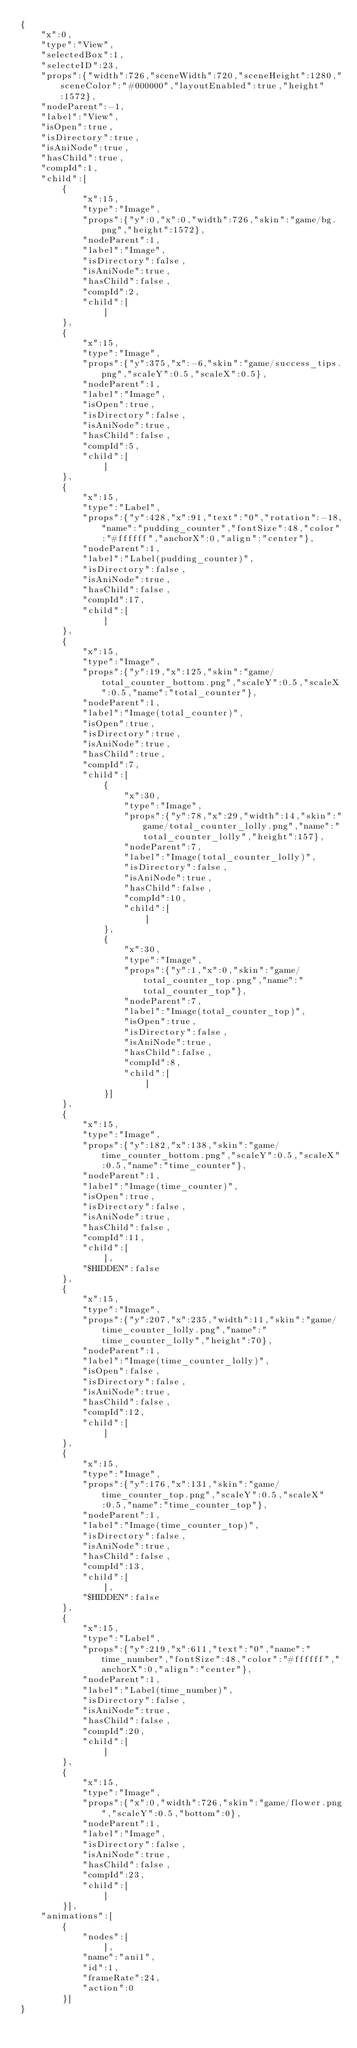<code> <loc_0><loc_0><loc_500><loc_500><_XML_>{
    "x":0,
    "type":"View",
    "selectedBox":1,
    "selecteID":23,
    "props":{"width":726,"sceneWidth":720,"sceneHeight":1280,"sceneColor":"#000000","layoutEnabled":true,"height":1572},
    "nodeParent":-1,
    "label":"View",
    "isOpen":true,
    "isDirectory":true,
    "isAniNode":true,
    "hasChild":true,
    "compId":1,
    "child":[
        {
            "x":15,
            "type":"Image",
            "props":{"y":0,"x":0,"width":726,"skin":"game/bg.png","height":1572},
            "nodeParent":1,
            "label":"Image",
            "isDirectory":false,
            "isAniNode":true,
            "hasChild":false,
            "compId":2,
            "child":[
                ]
        },
        {
            "x":15,
            "type":"Image",
            "props":{"y":375,"x":-6,"skin":"game/success_tips.png","scaleY":0.5,"scaleX":0.5},
            "nodeParent":1,
            "label":"Image",
            "isOpen":true,
            "isDirectory":false,
            "isAniNode":true,
            "hasChild":false,
            "compId":5,
            "child":[
                ]
        },
        {
            "x":15,
            "type":"Label",
            "props":{"y":428,"x":91,"text":"0","rotation":-18,"name":"pudding_counter","fontSize":48,"color":"#ffffff","anchorX":0,"align":"center"},
            "nodeParent":1,
            "label":"Label(pudding_counter)",
            "isDirectory":false,
            "isAniNode":true,
            "hasChild":false,
            "compId":17,
            "child":[
                ]
        },
        {
            "x":15,
            "type":"Image",
            "props":{"y":19,"x":125,"skin":"game/total_counter_bottom.png","scaleY":0.5,"scaleX":0.5,"name":"total_counter"},
            "nodeParent":1,
            "label":"Image(total_counter)",
            "isOpen":true,
            "isDirectory":true,
            "isAniNode":true,
            "hasChild":true,
            "compId":7,
            "child":[
                {
                    "x":30,
                    "type":"Image",
                    "props":{"y":78,"x":29,"width":14,"skin":"game/total_counter_lolly.png","name":"total_counter_lolly","height":157},
                    "nodeParent":7,
                    "label":"Image(total_counter_lolly)",
                    "isDirectory":false,
                    "isAniNode":true,
                    "hasChild":false,
                    "compId":10,
                    "child":[
                        ]
                },
                {
                    "x":30,
                    "type":"Image",
                    "props":{"y":1,"x":0,"skin":"game/total_counter_top.png","name":"total_counter_top"},
                    "nodeParent":7,
                    "label":"Image(total_counter_top)",
                    "isOpen":true,
                    "isDirectory":false,
                    "isAniNode":true,
                    "hasChild":false,
                    "compId":8,
                    "child":[
                        ]
                }]
        },
        {
            "x":15,
            "type":"Image",
            "props":{"y":182,"x":138,"skin":"game/time_counter_bottom.png","scaleY":0.5,"scaleX":0.5,"name":"time_counter"},
            "nodeParent":1,
            "label":"Image(time_counter)",
            "isOpen":true,
            "isDirectory":false,
            "isAniNode":true,
            "hasChild":false,
            "compId":11,
            "child":[
                ],
            "$HIDDEN":false
        },
        {
            "x":15,
            "type":"Image",
            "props":{"y":207,"x":235,"width":11,"skin":"game/time_counter_lolly.png","name":"time_counter_lolly","height":70},
            "nodeParent":1,
            "label":"Image(time_counter_lolly)",
            "isOpen":false,
            "isDirectory":false,
            "isAniNode":true,
            "hasChild":false,
            "compId":12,
            "child":[
                ]
        },
        {
            "x":15,
            "type":"Image",
            "props":{"y":176,"x":131,"skin":"game/time_counter_top.png","scaleY":0.5,"scaleX":0.5,"name":"time_counter_top"},
            "nodeParent":1,
            "label":"Image(time_counter_top)",
            "isDirectory":false,
            "isAniNode":true,
            "hasChild":false,
            "compId":13,
            "child":[
                ],
            "$HIDDEN":false
        },
        {
            "x":15,
            "type":"Label",
            "props":{"y":219,"x":611,"text":"0","name":"time_number","fontSize":48,"color":"#ffffff","anchorX":0,"align":"center"},
            "nodeParent":1,
            "label":"Label(time_number)",
            "isDirectory":false,
            "isAniNode":true,
            "hasChild":false,
            "compId":20,
            "child":[
                ]
        },
        {
            "x":15,
            "type":"Image",
            "props":{"x":0,"width":726,"skin":"game/flower.png","scaleY":0.5,"bottom":0},
            "nodeParent":1,
            "label":"Image",
            "isDirectory":false,
            "isAniNode":true,
            "hasChild":false,
            "compId":23,
            "child":[
                ]
        }],
    "animations":[
        {
            "nodes":[
                ],
            "name":"ani1",
            "id":1,
            "frameRate":24,
            "action":0
        }]
}</code> 